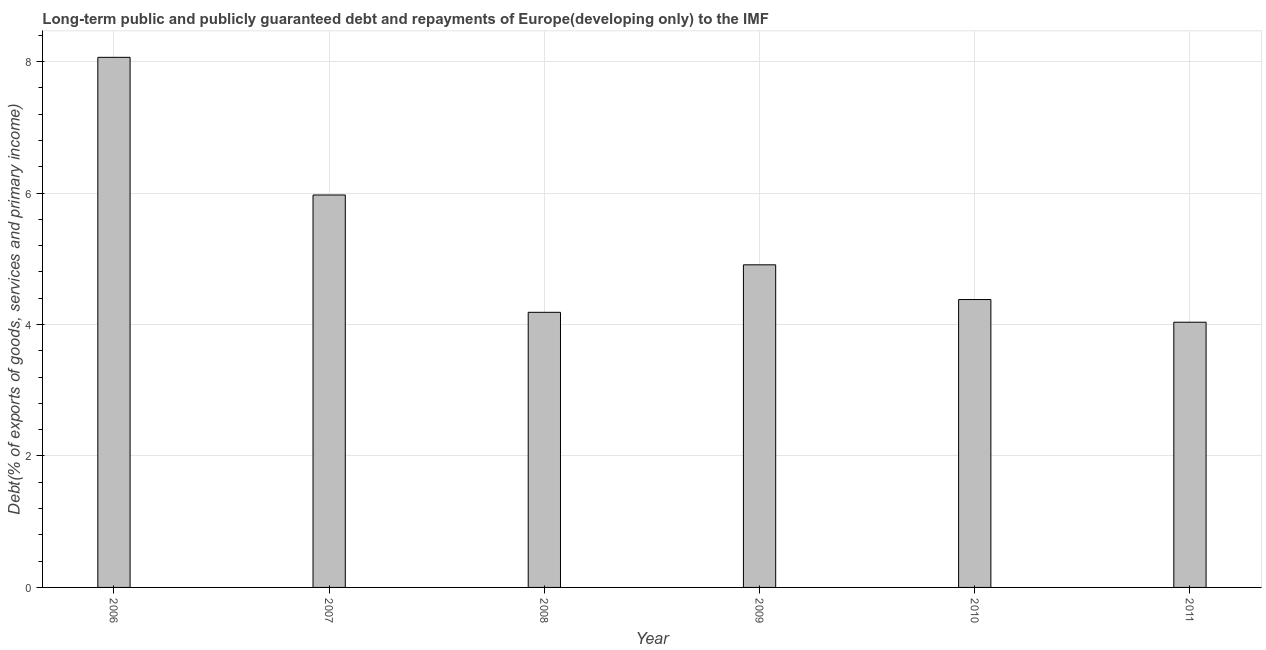Does the graph contain any zero values?
Provide a succinct answer. No. What is the title of the graph?
Make the answer very short. Long-term public and publicly guaranteed debt and repayments of Europe(developing only) to the IMF. What is the label or title of the Y-axis?
Your answer should be very brief. Debt(% of exports of goods, services and primary income). What is the debt service in 2011?
Keep it short and to the point. 4.03. Across all years, what is the maximum debt service?
Give a very brief answer. 8.06. Across all years, what is the minimum debt service?
Your answer should be compact. 4.03. What is the sum of the debt service?
Provide a short and direct response. 31.54. What is the difference between the debt service in 2009 and 2010?
Your answer should be compact. 0.53. What is the average debt service per year?
Offer a very short reply. 5.26. What is the median debt service?
Give a very brief answer. 4.64. In how many years, is the debt service greater than 2 %?
Give a very brief answer. 6. Do a majority of the years between 2006 and 2007 (inclusive) have debt service greater than 2.8 %?
Provide a succinct answer. Yes. Is the difference between the debt service in 2009 and 2011 greater than the difference between any two years?
Ensure brevity in your answer.  No. What is the difference between the highest and the second highest debt service?
Provide a short and direct response. 2.09. What is the difference between the highest and the lowest debt service?
Keep it short and to the point. 4.03. How many years are there in the graph?
Make the answer very short. 6. What is the difference between two consecutive major ticks on the Y-axis?
Your answer should be compact. 2. What is the Debt(% of exports of goods, services and primary income) of 2006?
Keep it short and to the point. 8.06. What is the Debt(% of exports of goods, services and primary income) of 2007?
Give a very brief answer. 5.97. What is the Debt(% of exports of goods, services and primary income) in 2008?
Offer a terse response. 4.18. What is the Debt(% of exports of goods, services and primary income) in 2009?
Your response must be concise. 4.91. What is the Debt(% of exports of goods, services and primary income) of 2010?
Your response must be concise. 4.38. What is the Debt(% of exports of goods, services and primary income) of 2011?
Your answer should be very brief. 4.03. What is the difference between the Debt(% of exports of goods, services and primary income) in 2006 and 2007?
Your response must be concise. 2.09. What is the difference between the Debt(% of exports of goods, services and primary income) in 2006 and 2008?
Offer a very short reply. 3.88. What is the difference between the Debt(% of exports of goods, services and primary income) in 2006 and 2009?
Your response must be concise. 3.16. What is the difference between the Debt(% of exports of goods, services and primary income) in 2006 and 2010?
Provide a short and direct response. 3.68. What is the difference between the Debt(% of exports of goods, services and primary income) in 2006 and 2011?
Your answer should be very brief. 4.03. What is the difference between the Debt(% of exports of goods, services and primary income) in 2007 and 2008?
Your answer should be very brief. 1.78. What is the difference between the Debt(% of exports of goods, services and primary income) in 2007 and 2009?
Provide a short and direct response. 1.06. What is the difference between the Debt(% of exports of goods, services and primary income) in 2007 and 2010?
Offer a terse response. 1.59. What is the difference between the Debt(% of exports of goods, services and primary income) in 2007 and 2011?
Your answer should be very brief. 1.94. What is the difference between the Debt(% of exports of goods, services and primary income) in 2008 and 2009?
Keep it short and to the point. -0.72. What is the difference between the Debt(% of exports of goods, services and primary income) in 2008 and 2010?
Your response must be concise. -0.19. What is the difference between the Debt(% of exports of goods, services and primary income) in 2008 and 2011?
Make the answer very short. 0.15. What is the difference between the Debt(% of exports of goods, services and primary income) in 2009 and 2010?
Your answer should be very brief. 0.53. What is the difference between the Debt(% of exports of goods, services and primary income) in 2009 and 2011?
Keep it short and to the point. 0.87. What is the difference between the Debt(% of exports of goods, services and primary income) in 2010 and 2011?
Keep it short and to the point. 0.34. What is the ratio of the Debt(% of exports of goods, services and primary income) in 2006 to that in 2007?
Keep it short and to the point. 1.35. What is the ratio of the Debt(% of exports of goods, services and primary income) in 2006 to that in 2008?
Keep it short and to the point. 1.93. What is the ratio of the Debt(% of exports of goods, services and primary income) in 2006 to that in 2009?
Offer a terse response. 1.64. What is the ratio of the Debt(% of exports of goods, services and primary income) in 2006 to that in 2010?
Offer a terse response. 1.84. What is the ratio of the Debt(% of exports of goods, services and primary income) in 2006 to that in 2011?
Offer a very short reply. 2. What is the ratio of the Debt(% of exports of goods, services and primary income) in 2007 to that in 2008?
Your answer should be compact. 1.43. What is the ratio of the Debt(% of exports of goods, services and primary income) in 2007 to that in 2009?
Make the answer very short. 1.22. What is the ratio of the Debt(% of exports of goods, services and primary income) in 2007 to that in 2010?
Your response must be concise. 1.36. What is the ratio of the Debt(% of exports of goods, services and primary income) in 2007 to that in 2011?
Give a very brief answer. 1.48. What is the ratio of the Debt(% of exports of goods, services and primary income) in 2008 to that in 2009?
Offer a very short reply. 0.85. What is the ratio of the Debt(% of exports of goods, services and primary income) in 2008 to that in 2010?
Keep it short and to the point. 0.96. What is the ratio of the Debt(% of exports of goods, services and primary income) in 2009 to that in 2010?
Ensure brevity in your answer.  1.12. What is the ratio of the Debt(% of exports of goods, services and primary income) in 2009 to that in 2011?
Give a very brief answer. 1.22. What is the ratio of the Debt(% of exports of goods, services and primary income) in 2010 to that in 2011?
Offer a terse response. 1.08. 